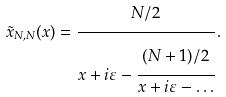Convert formula to latex. <formula><loc_0><loc_0><loc_500><loc_500>\tilde { x } _ { N , N } ( x ) = \cfrac { N / 2 } { x + i \varepsilon - \cfrac { ( N + 1 ) / 2 } { x + i \varepsilon - \dots } } \, .</formula> 